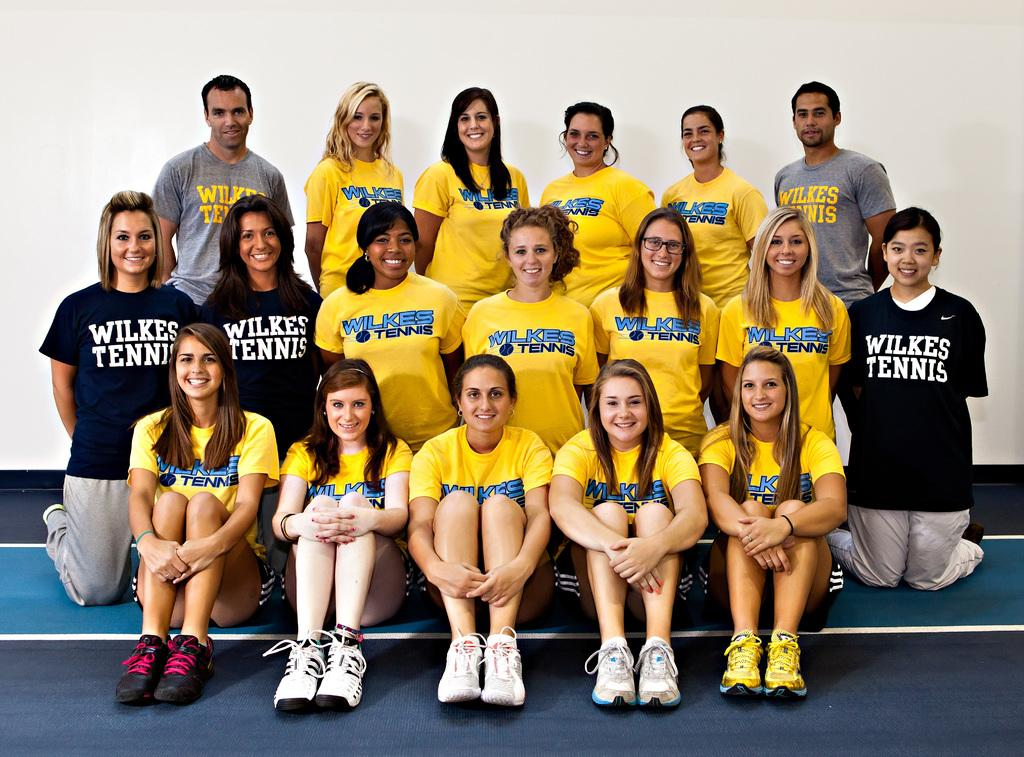<image>
Give a short and clear explanation of the subsequent image. The Wilkes tennis team gathers for a team photo, both players and coaches. 